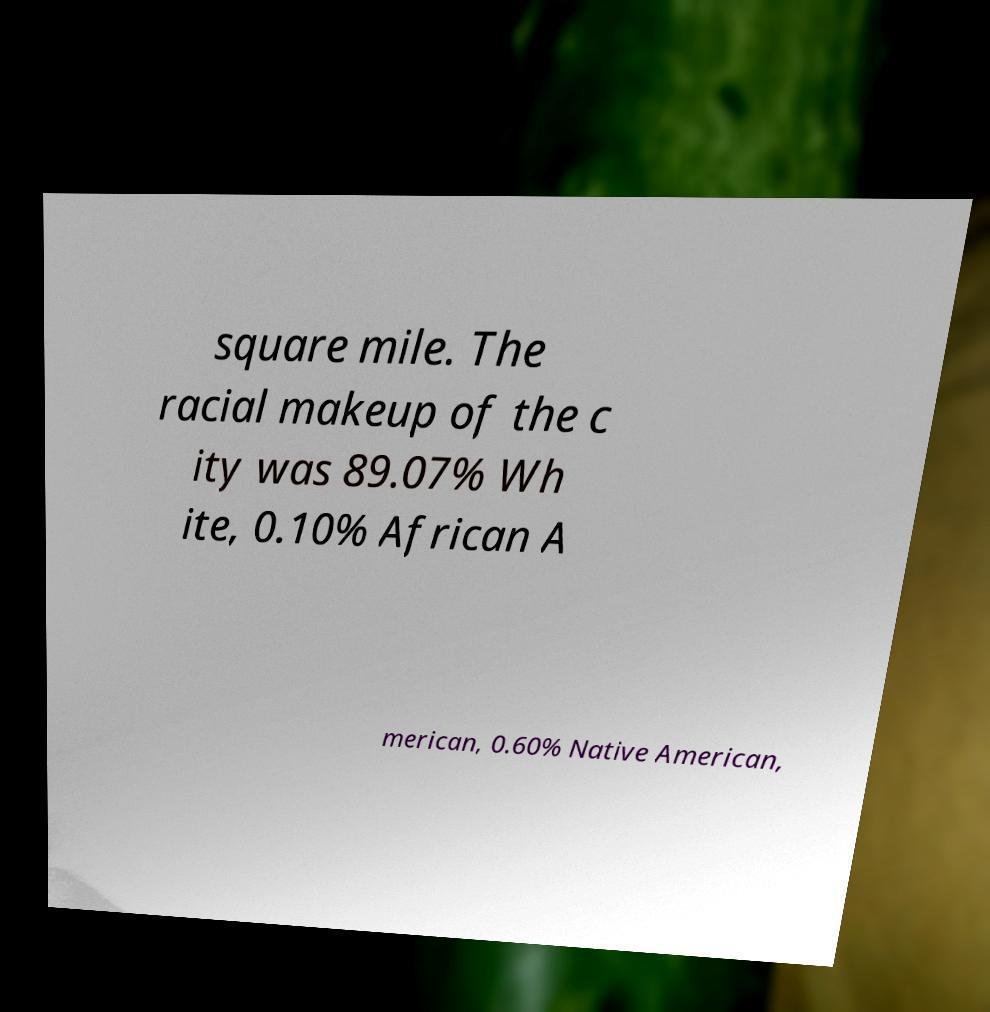For documentation purposes, I need the text within this image transcribed. Could you provide that? square mile. The racial makeup of the c ity was 89.07% Wh ite, 0.10% African A merican, 0.60% Native American, 